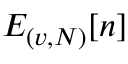Convert formula to latex. <formula><loc_0><loc_0><loc_500><loc_500>E _ { ( v , N ) } [ n ]</formula> 